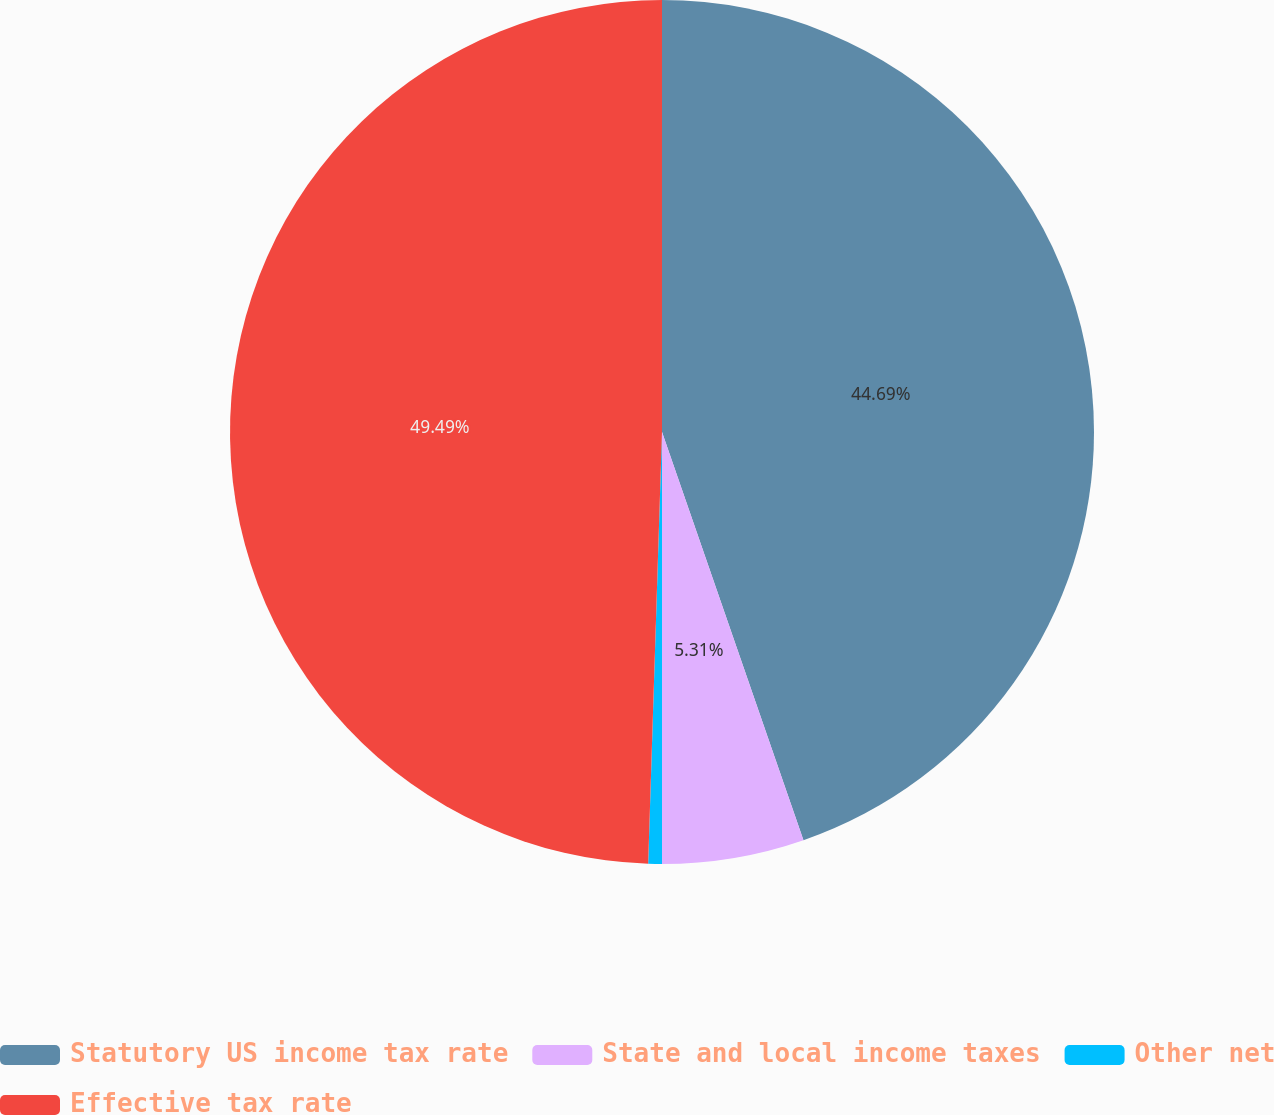Convert chart. <chart><loc_0><loc_0><loc_500><loc_500><pie_chart><fcel>Statutory US income tax rate<fcel>State and local income taxes<fcel>Other net<fcel>Effective tax rate<nl><fcel>44.69%<fcel>5.31%<fcel>0.51%<fcel>49.49%<nl></chart> 